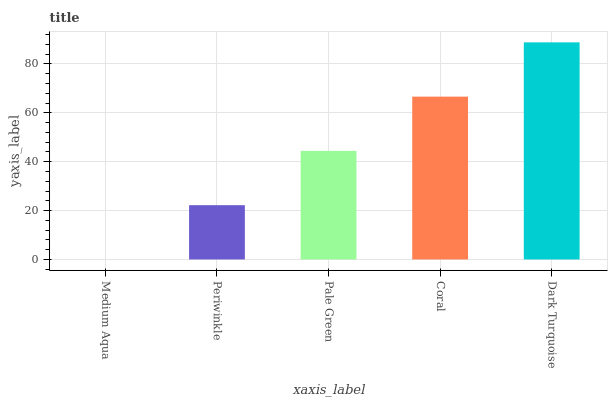Is Medium Aqua the minimum?
Answer yes or no. Yes. Is Dark Turquoise the maximum?
Answer yes or no. Yes. Is Periwinkle the minimum?
Answer yes or no. No. Is Periwinkle the maximum?
Answer yes or no. No. Is Periwinkle greater than Medium Aqua?
Answer yes or no. Yes. Is Medium Aqua less than Periwinkle?
Answer yes or no. Yes. Is Medium Aqua greater than Periwinkle?
Answer yes or no. No. Is Periwinkle less than Medium Aqua?
Answer yes or no. No. Is Pale Green the high median?
Answer yes or no. Yes. Is Pale Green the low median?
Answer yes or no. Yes. Is Medium Aqua the high median?
Answer yes or no. No. Is Medium Aqua the low median?
Answer yes or no. No. 